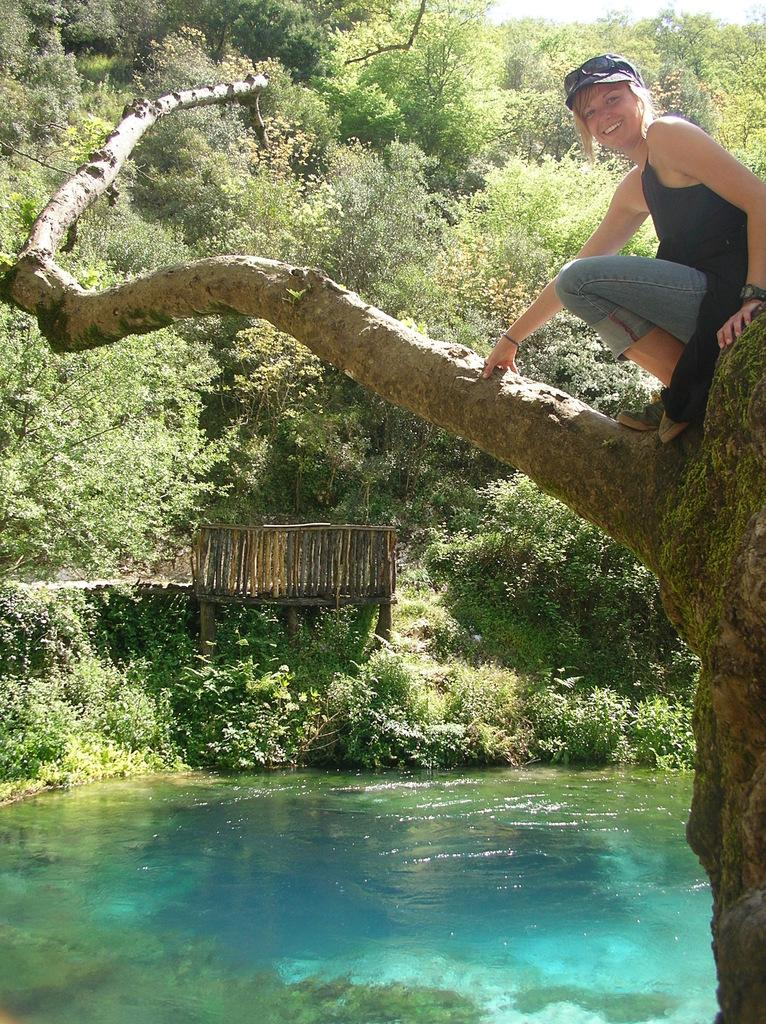What is the person in the image doing? There is a person on a tree on the right side of the image. What can be seen in the image besides the person on the tree? There is water visible in the image. What is located on the left side of the image? There is a wooden fence on the left side of the image. What is visible in the background of the image? Trees are present in the background of the image. What type of meat is being grilled near the water in the image? There is no meat or grill present in the image; it only features a person on a tree, water, a wooden fence, and trees in the background. 